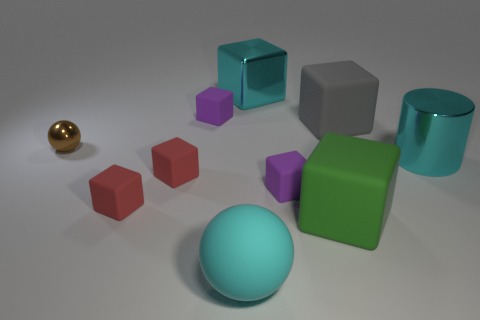Is there a rubber object of the same color as the big shiny cylinder?
Keep it short and to the point. Yes. Is the color of the large metal thing behind the brown metal object the same as the cylinder?
Your response must be concise. Yes. The cylinder that is the same size as the green rubber cube is what color?
Provide a short and direct response. Cyan. Does the metallic thing behind the brown metal object have the same shape as the large green matte object?
Offer a very short reply. Yes. The sphere that is behind the red rubber object that is in front of the small purple matte object in front of the tiny brown metal ball is what color?
Offer a very short reply. Brown. Are there any cyan rubber things?
Your response must be concise. Yes. What number of other objects are the same size as the cyan matte thing?
Provide a succinct answer. 4. Do the big ball and the large metallic thing that is in front of the large metallic block have the same color?
Provide a short and direct response. Yes. What number of things are large gray matte blocks or purple objects?
Give a very brief answer. 3. Is there anything else of the same color as the large rubber ball?
Your response must be concise. Yes. 